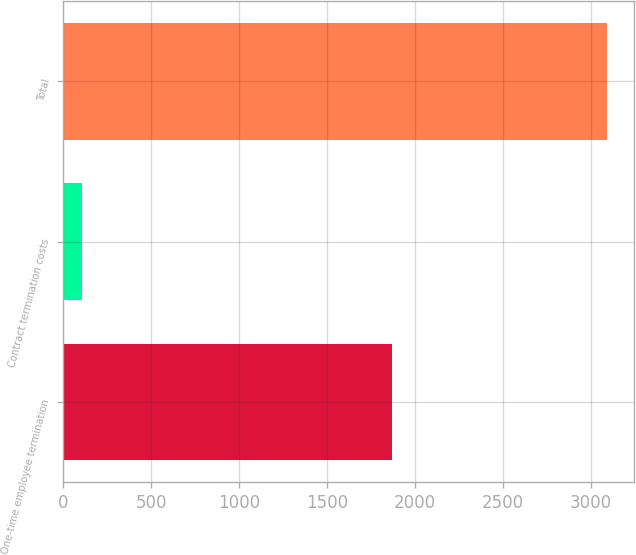Convert chart. <chart><loc_0><loc_0><loc_500><loc_500><bar_chart><fcel>One-time employee termination<fcel>Contract termination costs<fcel>Total<nl><fcel>1866<fcel>104<fcel>3088<nl></chart> 